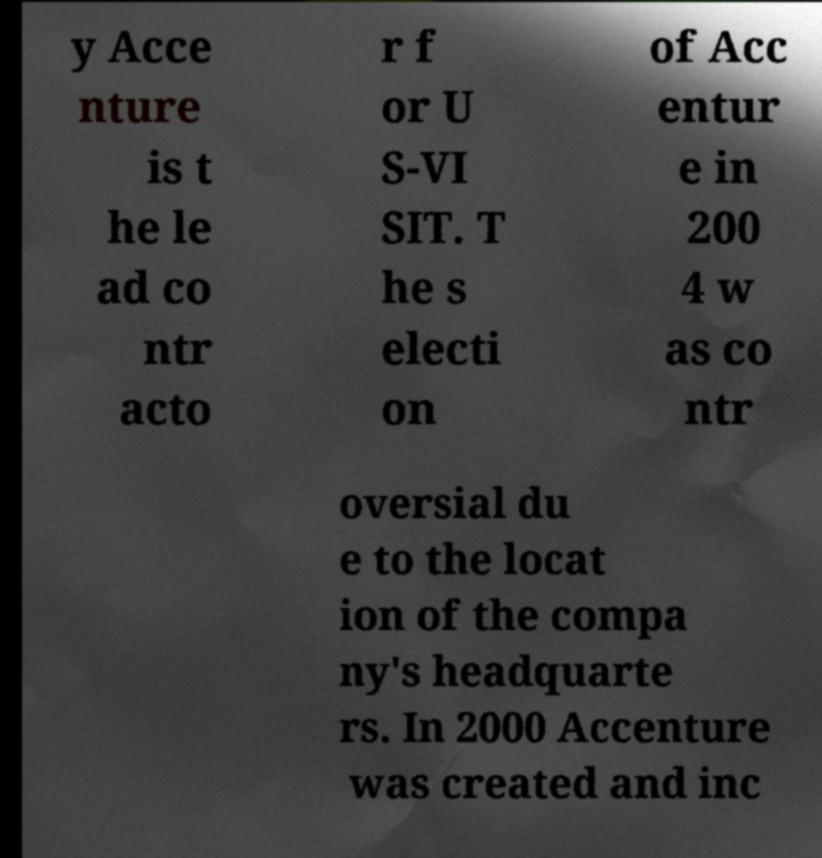Please read and relay the text visible in this image. What does it say? y Acce nture is t he le ad co ntr acto r f or U S-VI SIT. T he s electi on of Acc entur e in 200 4 w as co ntr oversial du e to the locat ion of the compa ny's headquarte rs. In 2000 Accenture was created and inc 